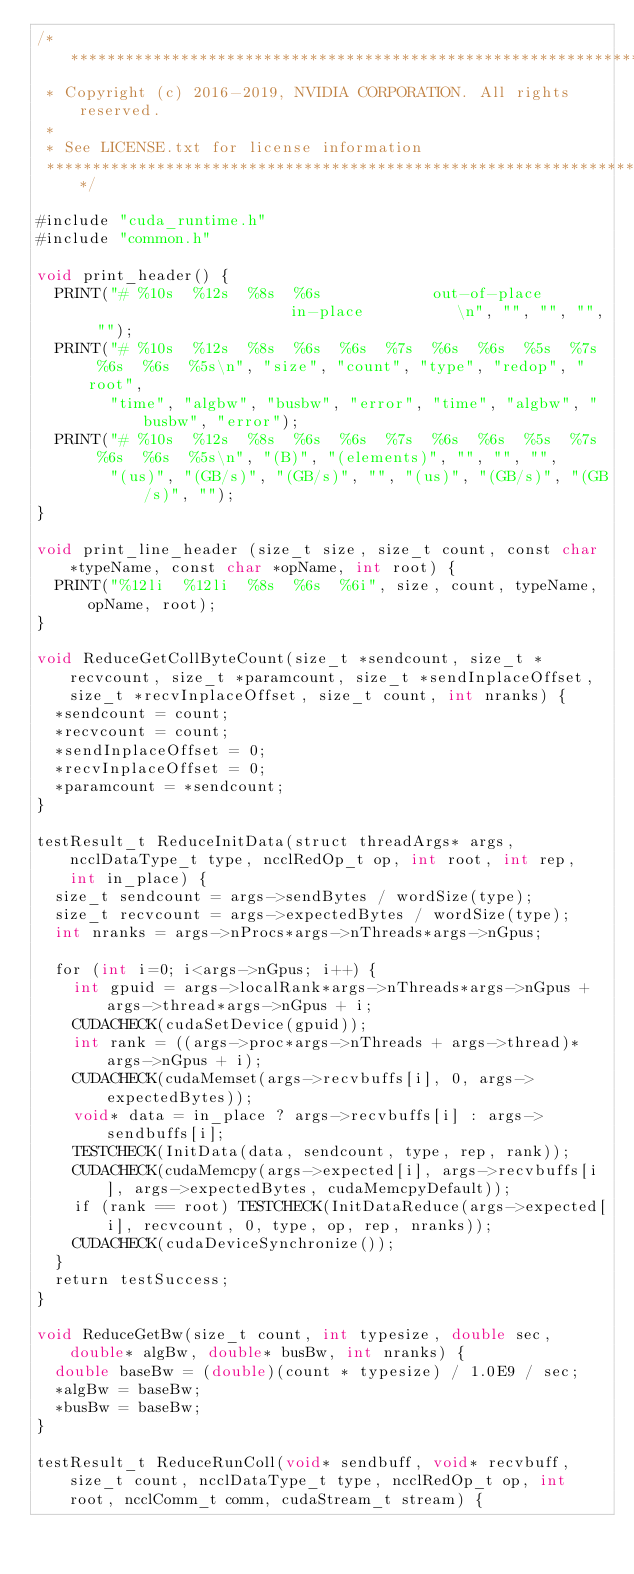Convert code to text. <code><loc_0><loc_0><loc_500><loc_500><_Cuda_>/*************************************************************************
 * Copyright (c) 2016-2019, NVIDIA CORPORATION. All rights reserved.
 *
 * See LICENSE.txt for license information
 ************************************************************************/

#include "cuda_runtime.h"
#include "common.h"

void print_header() {
  PRINT("# %10s  %12s  %8s  %6s            out-of-place                       in-place          \n", "", "", "", "");
  PRINT("# %10s  %12s  %8s  %6s  %6s  %7s  %6s  %6s  %5s  %7s  %6s  %6s  %5s\n", "size", "count", "type", "redop", "root",
        "time", "algbw", "busbw", "error", "time", "algbw", "busbw", "error");
  PRINT("# %10s  %12s  %8s  %6s  %6s  %7s  %6s  %6s  %5s  %7s  %6s  %6s  %5s\n", "(B)", "(elements)", "", "", "",
        "(us)", "(GB/s)", "(GB/s)", "", "(us)", "(GB/s)", "(GB/s)", "");
}

void print_line_header (size_t size, size_t count, const char *typeName, const char *opName, int root) {
  PRINT("%12li  %12li  %8s  %6s  %6i", size, count, typeName, opName, root);
}

void ReduceGetCollByteCount(size_t *sendcount, size_t *recvcount, size_t *paramcount, size_t *sendInplaceOffset, size_t *recvInplaceOffset, size_t count, int nranks) {
  *sendcount = count;
  *recvcount = count;
  *sendInplaceOffset = 0;
  *recvInplaceOffset = 0;
  *paramcount = *sendcount;
}

testResult_t ReduceInitData(struct threadArgs* args, ncclDataType_t type, ncclRedOp_t op, int root, int rep, int in_place) {
  size_t sendcount = args->sendBytes / wordSize(type);
  size_t recvcount = args->expectedBytes / wordSize(type);
  int nranks = args->nProcs*args->nThreads*args->nGpus;

  for (int i=0; i<args->nGpus; i++) {
    int gpuid = args->localRank*args->nThreads*args->nGpus + args->thread*args->nGpus + i;
    CUDACHECK(cudaSetDevice(gpuid));
    int rank = ((args->proc*args->nThreads + args->thread)*args->nGpus + i);
    CUDACHECK(cudaMemset(args->recvbuffs[i], 0, args->expectedBytes));
    void* data = in_place ? args->recvbuffs[i] : args->sendbuffs[i];
    TESTCHECK(InitData(data, sendcount, type, rep, rank));
    CUDACHECK(cudaMemcpy(args->expected[i], args->recvbuffs[i], args->expectedBytes, cudaMemcpyDefault));
    if (rank == root) TESTCHECK(InitDataReduce(args->expected[i], recvcount, 0, type, op, rep, nranks));
    CUDACHECK(cudaDeviceSynchronize());
  }
  return testSuccess;
}

void ReduceGetBw(size_t count, int typesize, double sec, double* algBw, double* busBw, int nranks) {
  double baseBw = (double)(count * typesize) / 1.0E9 / sec;
  *algBw = baseBw;
  *busBw = baseBw;
}

testResult_t ReduceRunColl(void* sendbuff, void* recvbuff, size_t count, ncclDataType_t type, ncclRedOp_t op, int root, ncclComm_t comm, cudaStream_t stream) {</code> 